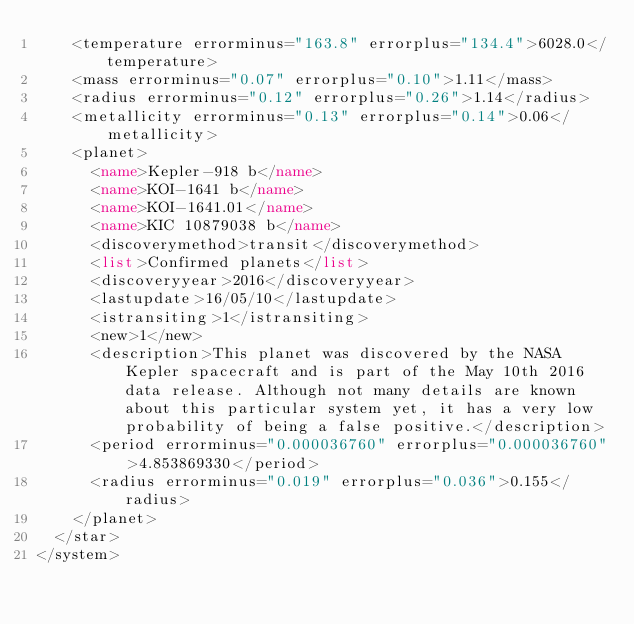Convert code to text. <code><loc_0><loc_0><loc_500><loc_500><_XML_>		<temperature errorminus="163.8" errorplus="134.4">6028.0</temperature>
		<mass errorminus="0.07" errorplus="0.10">1.11</mass>
		<radius errorminus="0.12" errorplus="0.26">1.14</radius>
		<metallicity errorminus="0.13" errorplus="0.14">0.06</metallicity>
		<planet>
			<name>Kepler-918 b</name>
			<name>KOI-1641 b</name>
			<name>KOI-1641.01</name>
			<name>KIC 10879038 b</name>
			<discoverymethod>transit</discoverymethod>
			<list>Confirmed planets</list>
			<discoveryyear>2016</discoveryyear>
			<lastupdate>16/05/10</lastupdate>
			<istransiting>1</istransiting>
			<new>1</new>
			<description>This planet was discovered by the NASA Kepler spacecraft and is part of the May 10th 2016 data release. Although not many details are known about this particular system yet, it has a very low probability of being a false positive.</description>
			<period errorminus="0.000036760" errorplus="0.000036760">4.853869330</period>
			<radius errorminus="0.019" errorplus="0.036">0.155</radius>
		</planet>
	</star>
</system>
</code> 